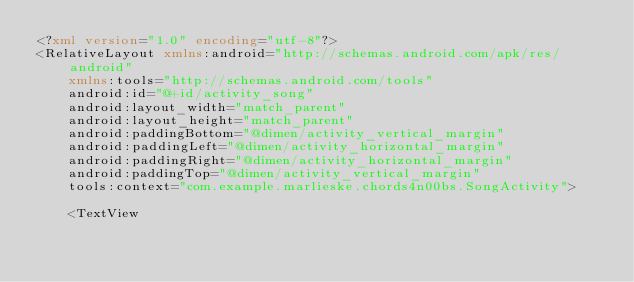<code> <loc_0><loc_0><loc_500><loc_500><_XML_><?xml version="1.0" encoding="utf-8"?>
<RelativeLayout xmlns:android="http://schemas.android.com/apk/res/android"
    xmlns:tools="http://schemas.android.com/tools"
    android:id="@+id/activity_song"
    android:layout_width="match_parent"
    android:layout_height="match_parent"
    android:paddingBottom="@dimen/activity_vertical_margin"
    android:paddingLeft="@dimen/activity_horizontal_margin"
    android:paddingRight="@dimen/activity_horizontal_margin"
    android:paddingTop="@dimen/activity_vertical_margin"
    tools:context="com.example.marlieske.chords4n00bs.SongActivity">

    <TextView</code> 